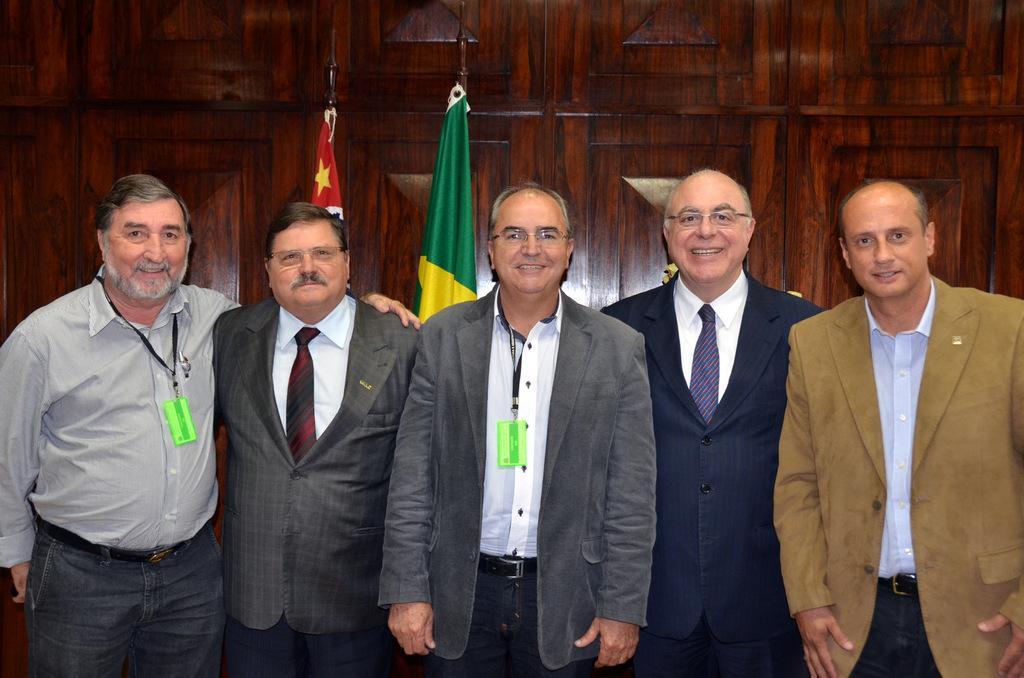In one or two sentences, can you explain what this image depicts? In front of the picture, we see five men are standing. They are smiling and they might be posing for the photo. Two of them are wearing the green ID cards. Behind them, we see the flags in red, yellow and green color. In the background, we see the wooden wall which is brown in color. 